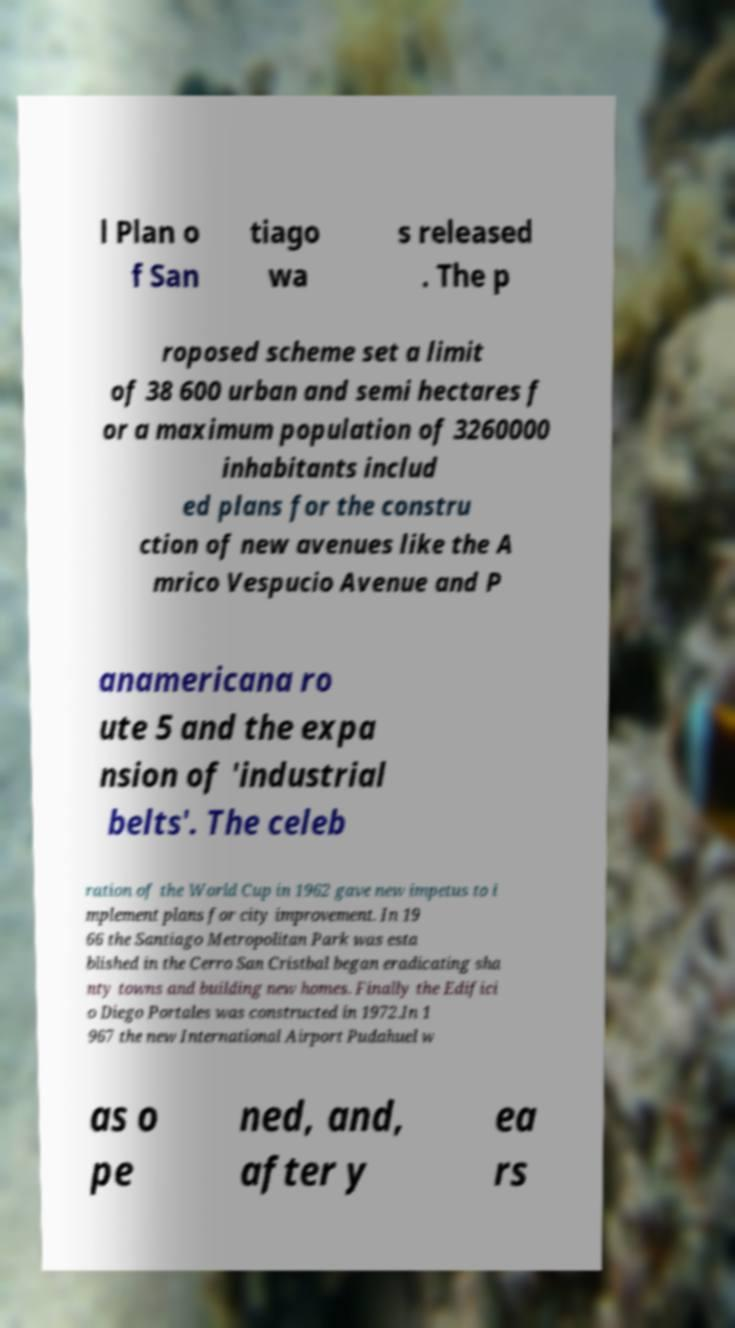Could you assist in decoding the text presented in this image and type it out clearly? l Plan o f San tiago wa s released . The p roposed scheme set a limit of 38 600 urban and semi hectares f or a maximum population of 3260000 inhabitants includ ed plans for the constru ction of new avenues like the A mrico Vespucio Avenue and P anamericana ro ute 5 and the expa nsion of 'industrial belts'. The celeb ration of the World Cup in 1962 gave new impetus to i mplement plans for city improvement. In 19 66 the Santiago Metropolitan Park was esta blished in the Cerro San Cristbal began eradicating sha nty towns and building new homes. Finally the Edifici o Diego Portales was constructed in 1972.In 1 967 the new International Airport Pudahuel w as o pe ned, and, after y ea rs 